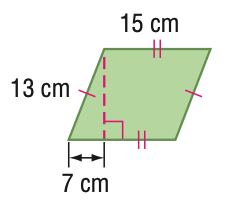Answer the mathemtical geometry problem and directly provide the correct option letter.
Question: Find the area of the figure. Round to the nearest tenth if necessary.
Choices: A: 56 B: 82.2 C: 164.3 D: 328.6 C 